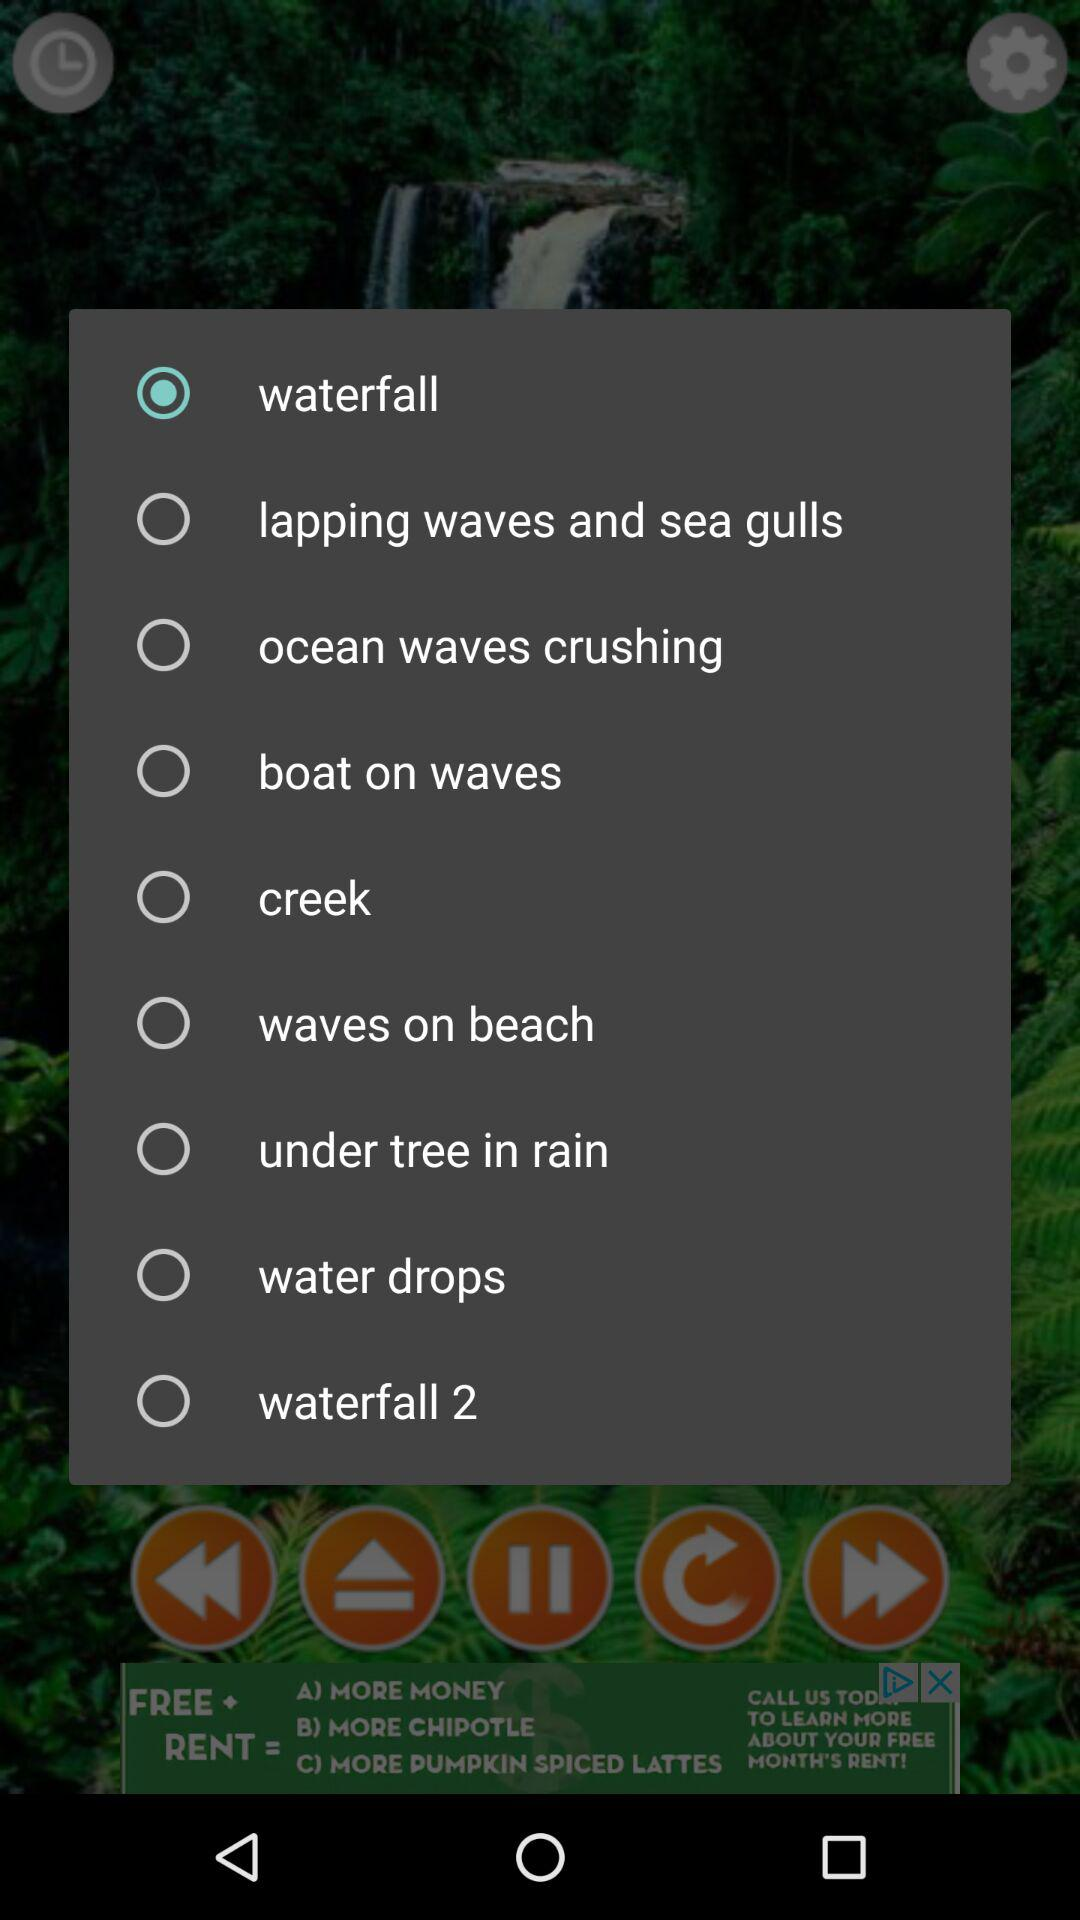Which option has been selected? The option "waterfall" has been selected. 